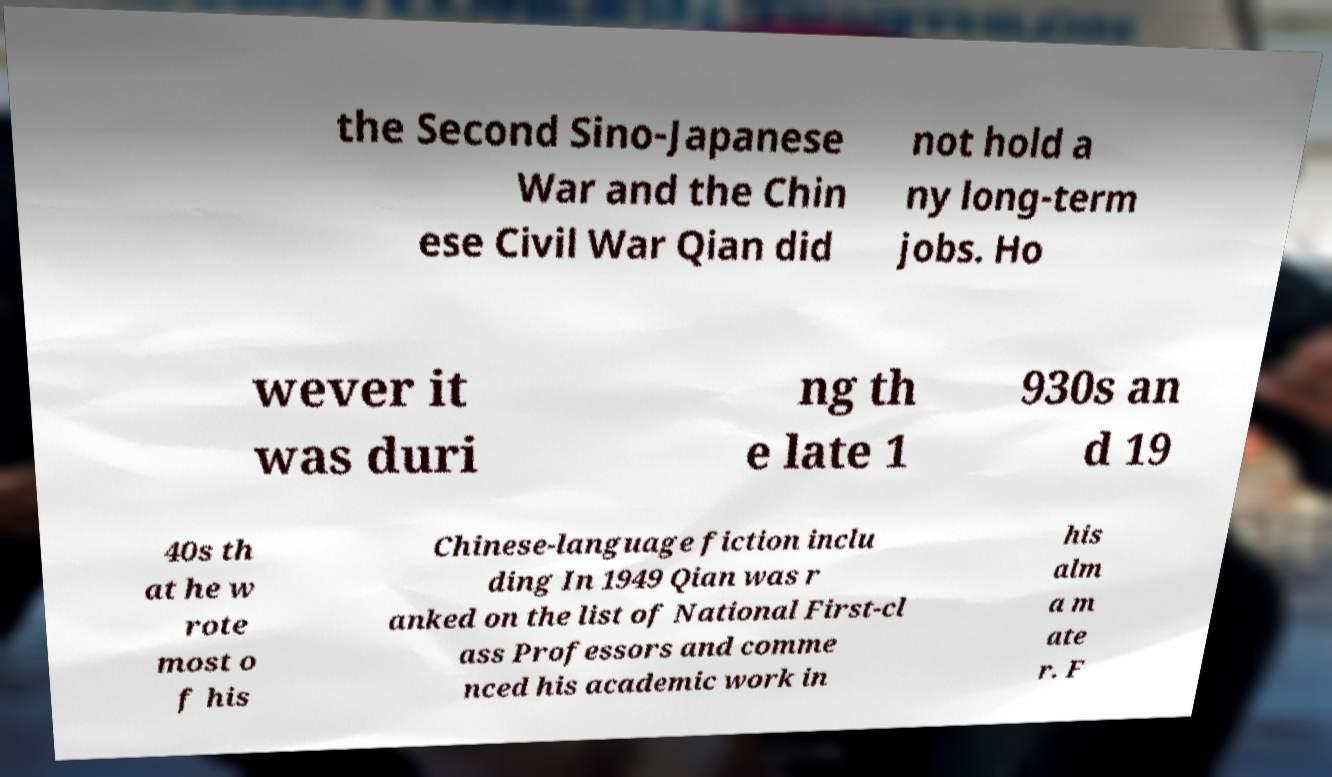Can you accurately transcribe the text from the provided image for me? the Second Sino-Japanese War and the Chin ese Civil War Qian did not hold a ny long-term jobs. Ho wever it was duri ng th e late 1 930s an d 19 40s th at he w rote most o f his Chinese-language fiction inclu ding In 1949 Qian was r anked on the list of National First-cl ass Professors and comme nced his academic work in his alm a m ate r. F 